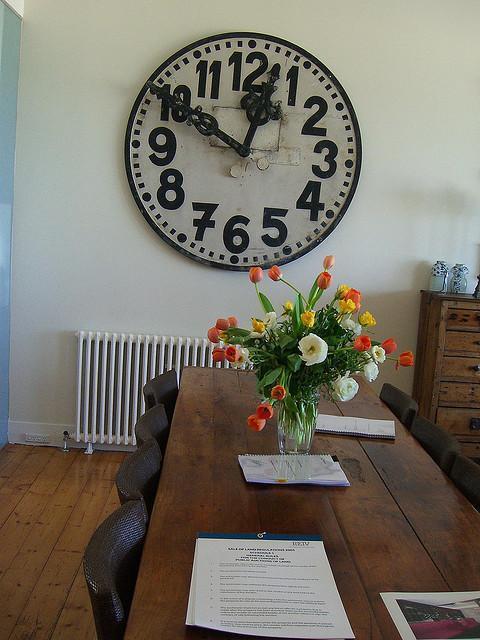How many plants are in the photo?
Give a very brief answer. 1. How many chairs are in the photo?
Give a very brief answer. 2. How many people are in this picture?
Give a very brief answer. 0. 